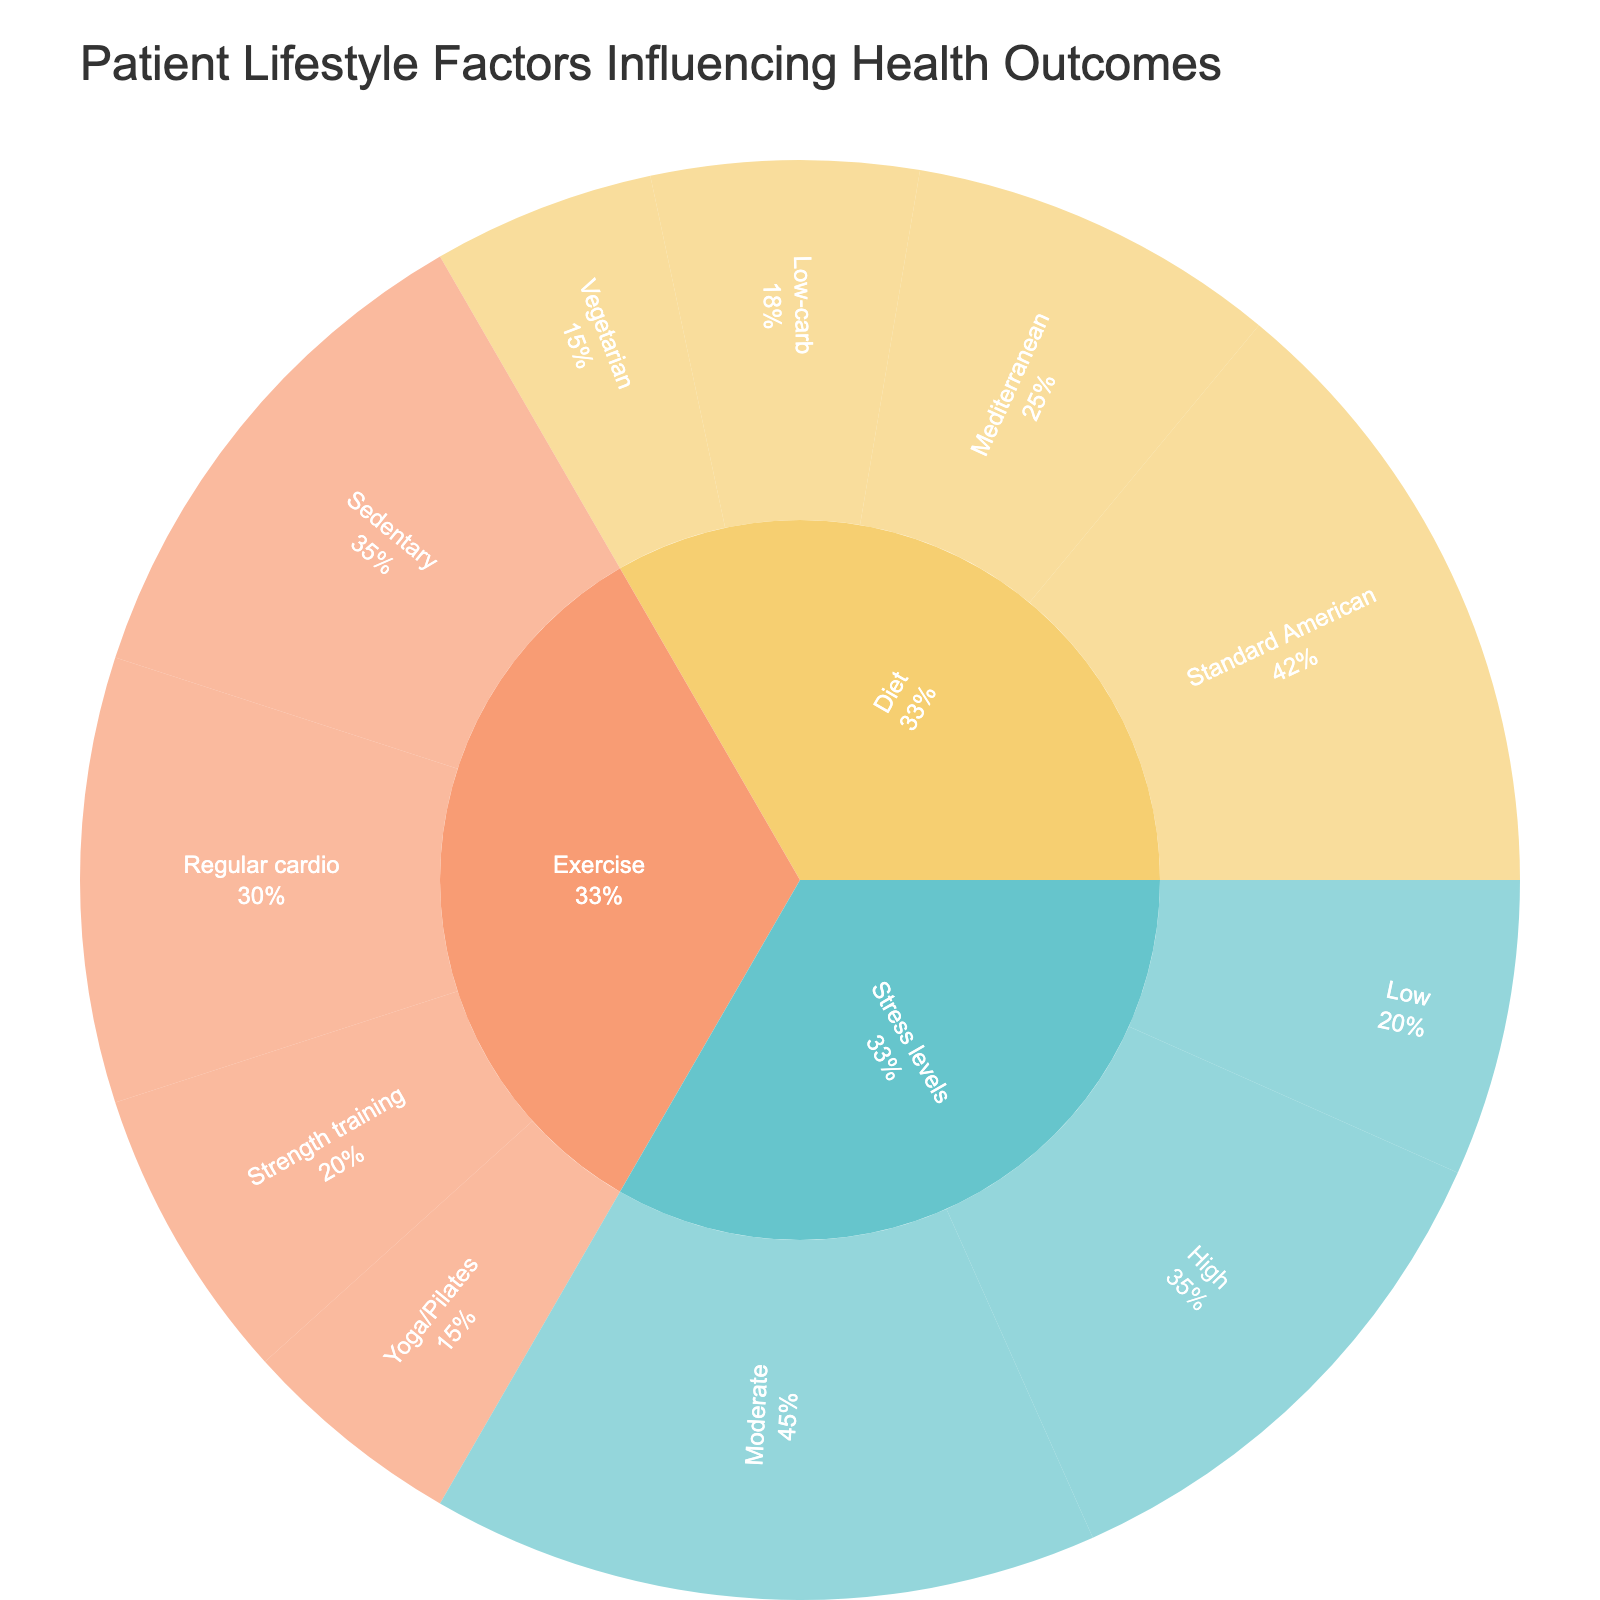What is the highest value subcategory within the Diet category? Look at the values of the subcategories under Diet, which are Mediterranean (25), Low-carb (18), Vegetarian (15), and Standard American (42). The highest value here is 42 under Standard American.
Answer: Standard American What is the total value of the Exercise category? Sum up the values of the subcategories under Exercise: Regular cardio (30), Strength training (20), Yoga/Pilates (15), and Sedentary (35). The total is 30 + 20 + 15 + 35 = 100.
Answer: 100 Which subcategory under Stress levels has the lowest value? Compare the values of Low (20), Moderate (45), and High (35). The lowest value is 20 under Low.
Answer: Low How does the highest value in Exercise compare to the highest in Diet? Identify the highest values in Exercise (Regular cardio: 30) and Diet (Standard American: 42). The highest in Diet (42) is greater than the highest in Exercise (30).
Answer: Diet is greater What percentage of the total value does the Moderate stress level subcategory represent within the Stress levels category? The total value for Stress levels is 20 + 45 + 35 = 100. The value for Moderate is 45. So, 45/100 * 100% = 45%.
Answer: 45% What's the combined value of the lowest subcategories in each category? Identify the lowest subcategory in each category: Diet (Vegetarian: 15), Exercise (Yoga/Pilates: 15), and Stress levels (Low: 20). Summing these values gives 15 + 15 + 20 = 50.
Answer: 50 Which category (Diet, Exercise, or Stress levels) has the lowest total value? Calculate the total values: Diet (25 + 18 + 15 + 42 = 100), Exercise (30 + 20 + 15 + 35 = 100), Stress levels (20 + 45 + 35 = 100). All categories have the same total value of 100.
Answer: All are equal What is the ratio of Sedentary exercise values to the combined values of Mediterranean and Low-carb diets? The value for Sedentary is 35. The combined values for Mediterranean and Low-carb are 25 + 18 = 43. The ratio is 35:43.
Answer: 35:43 Which category has the most evenly distributed values among its subcategories? Calculate the range of values in each category: Diet (42 - 15 = 27), Exercise (35 - 15 = 20), Stress levels (45 - 20 = 25). Exercise has the smallest range, indicating more even distribution.
Answer: Exercise What percentage of the total Sunburst plot value is represented by the High stress level? The total Sunburst plot value is the sum of all values: 100 (Diet) + 100 (Exercise) + 100 (Stress levels) = 300. The value for High stress level is 35. So, 35/300 * 100% ≈ 11.67%.
Answer: 11.67% 